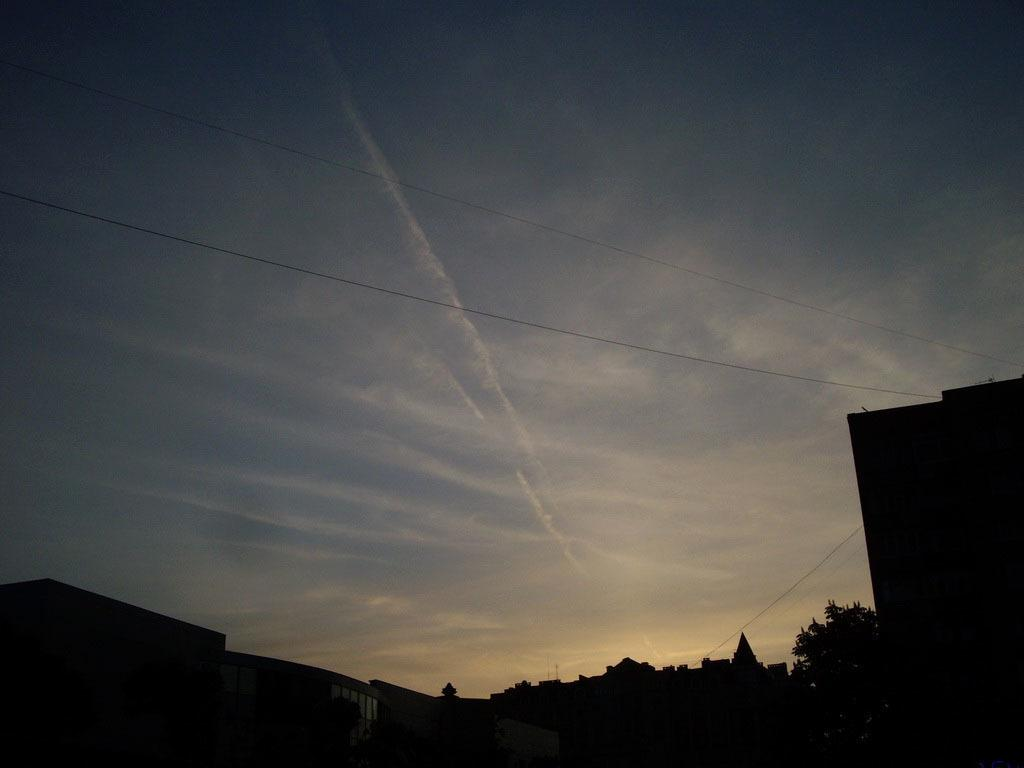What is visible in the background of the image? The sky is visible in the image. What can be seen in the sky? There are clouds in the sky. What type of natural elements are present in the image? There are trees in the image. What type of man-made structures are present in the image? There are buildings in the image. How would you describe the lighting in the image? The image appears to be dark. Can you see a parcel being delivered by a winged creature in the image? There is no parcel or winged creature present in the image. What type of basket is hanging from the tree in the image? There is no basket hanging from a tree in the image. 